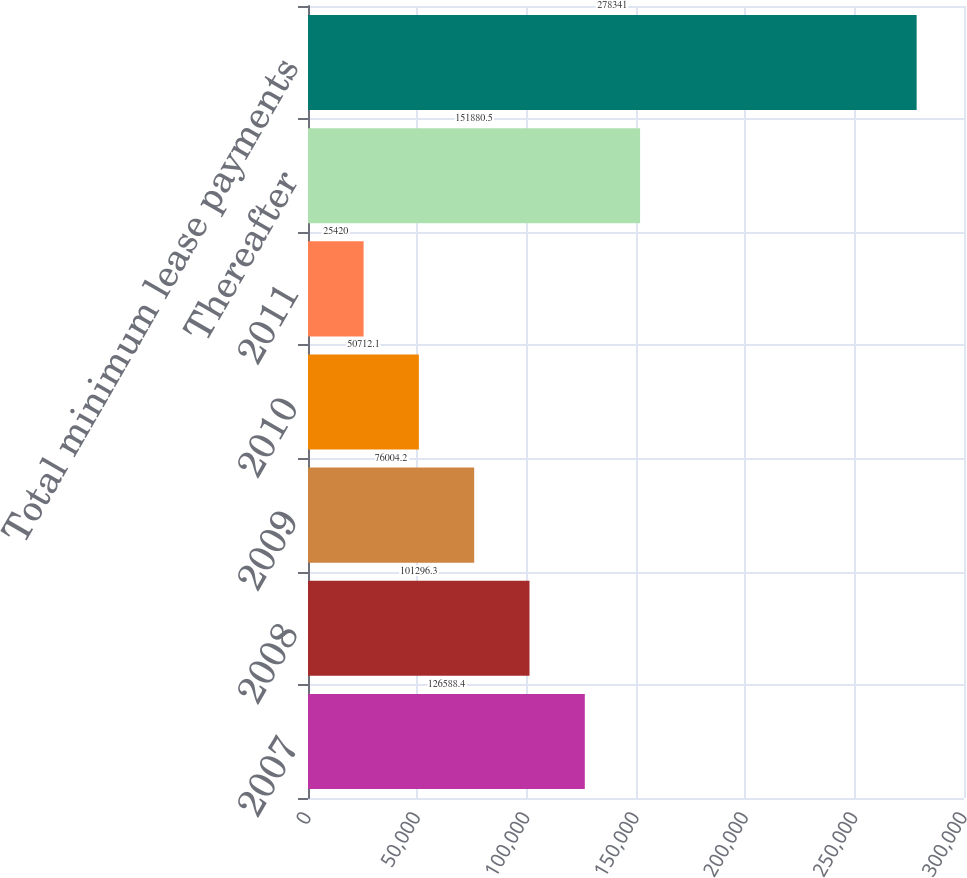Convert chart to OTSL. <chart><loc_0><loc_0><loc_500><loc_500><bar_chart><fcel>2007<fcel>2008<fcel>2009<fcel>2010<fcel>2011<fcel>Thereafter<fcel>Total minimum lease payments<nl><fcel>126588<fcel>101296<fcel>76004.2<fcel>50712.1<fcel>25420<fcel>151880<fcel>278341<nl></chart> 